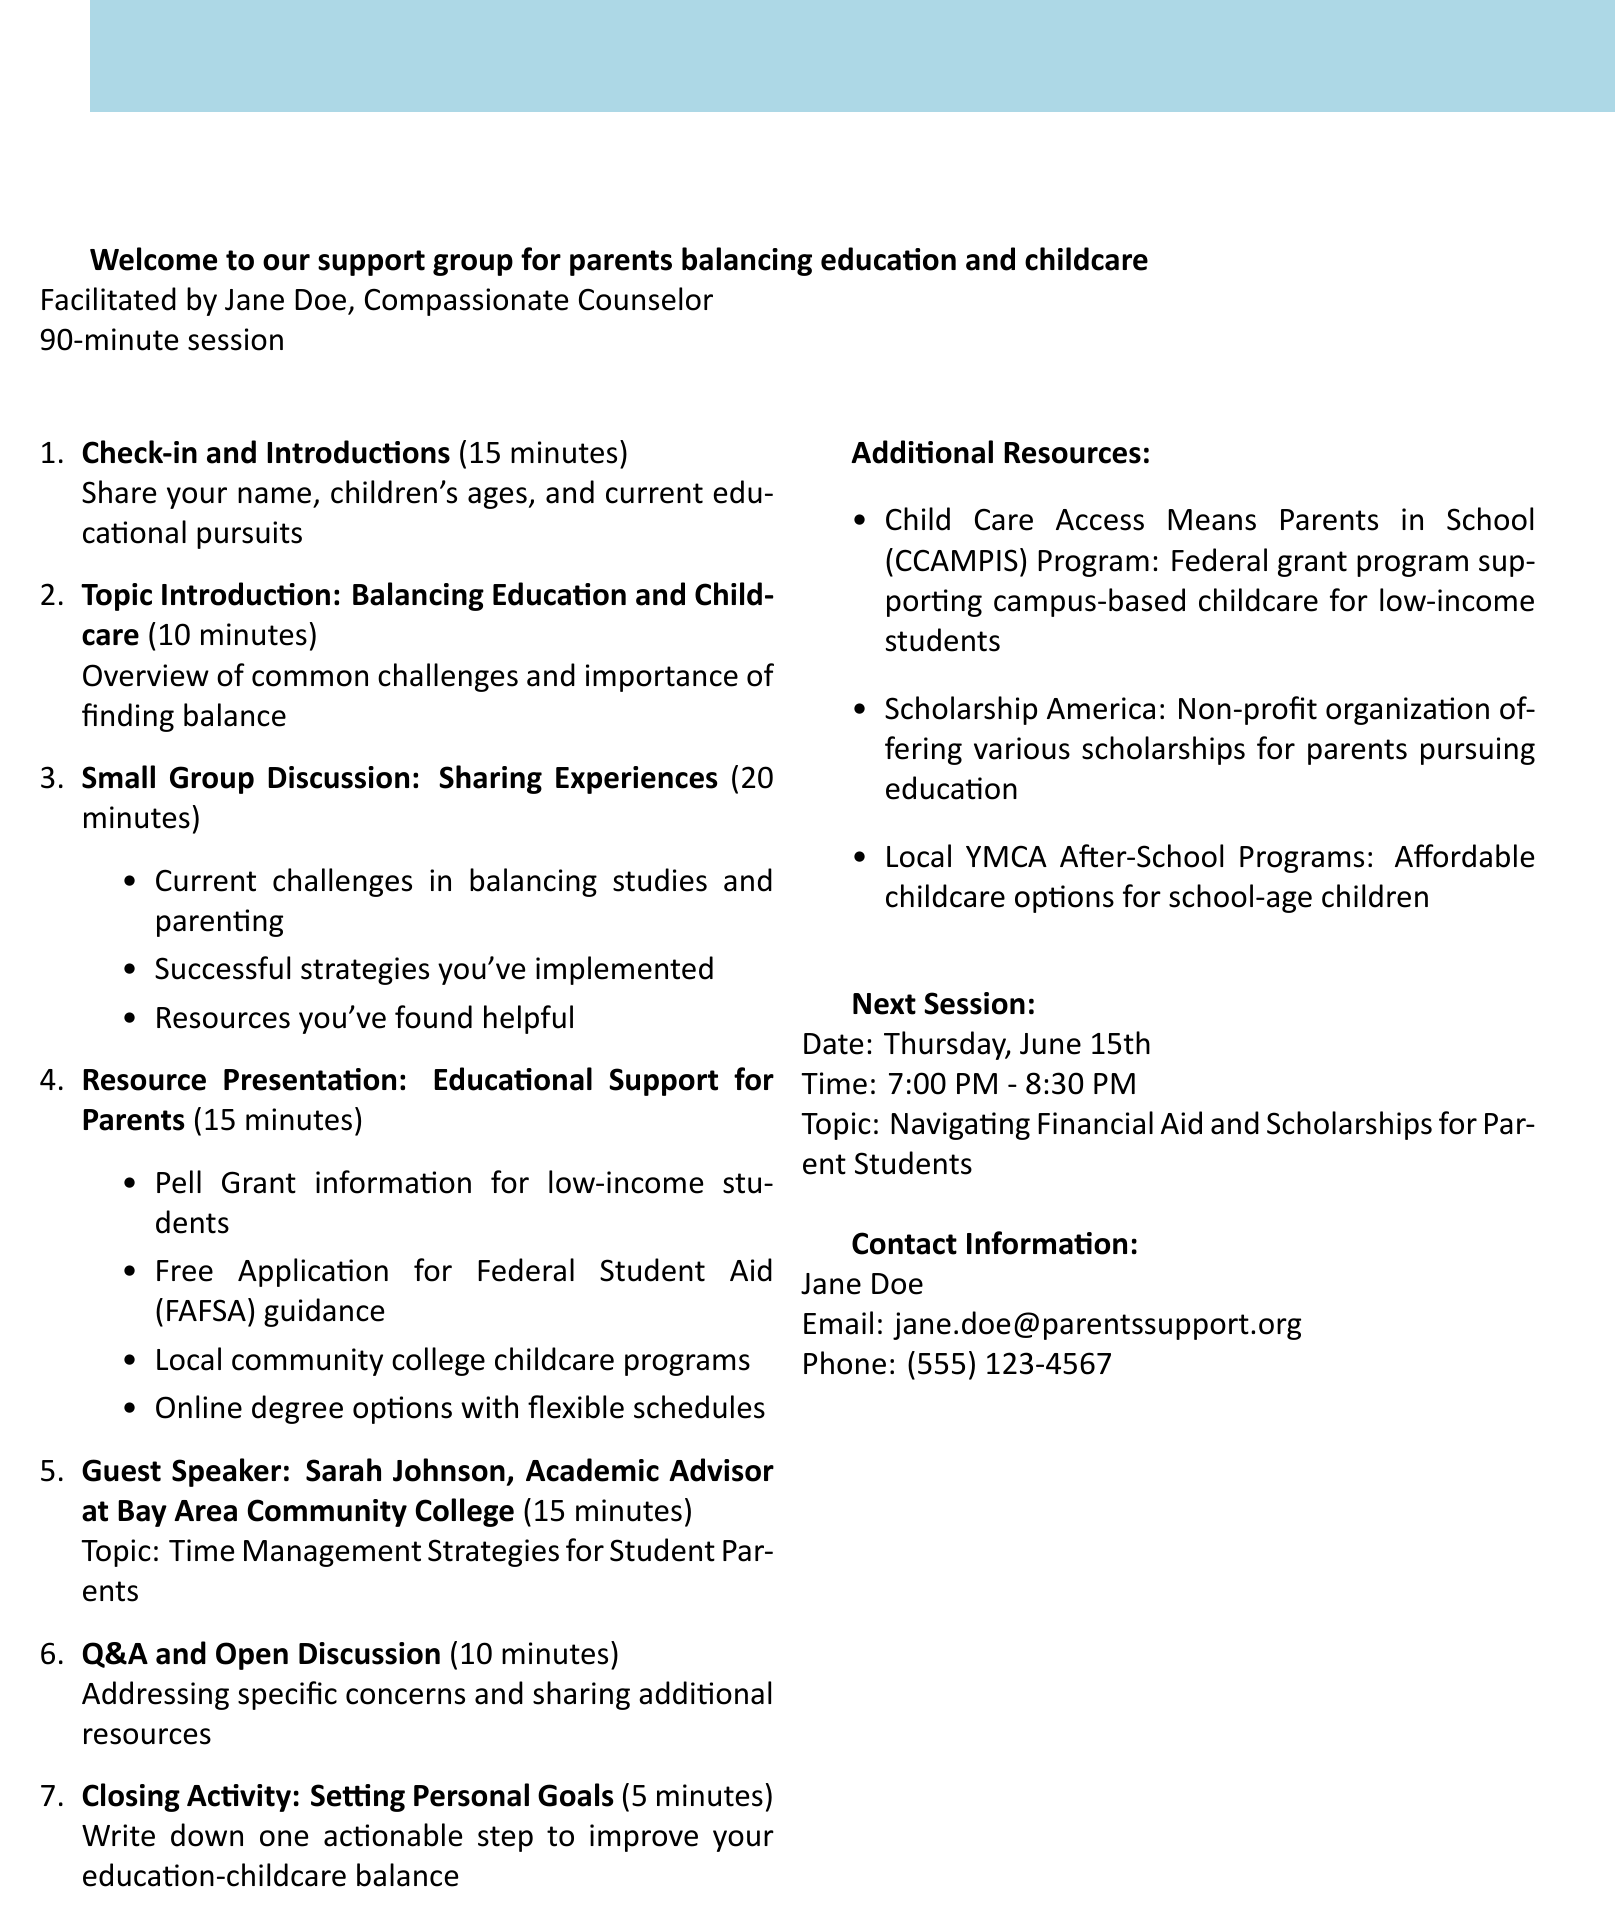What is the facilitator's name? The facilitator's name is mentioned in the introduction section of the document.
Answer: Jane Doe How long is the session scheduled for? The duration of the session is specified in the introduction section.
Answer: 90-minute session What is the date of the next session? The next session's date is provided in the document under the next session section.
Answer: Thursday, June 15th What topic will the guest speaker discuss? The topic of the guest speaker is listed in their section.
Answer: Time Management Strategies for Student Parents How many minutes are allocated for small group discussion? The duration for small group discussion is mentioned in the agenda items section.
Answer: 20 minutes What is one of the resources presented for educational support? The resources are listed in the resource presentation section of the agenda.
Answer: Pell Grant information for low-income students What is the last activity listed in the agenda? The final activity is mentioned at the end of the agenda items.
Answer: Closing Activity: Setting Personal Goals What organization offers scholarships for parents pursuing education? The additional resources section names organizations that provide scholarships.
Answer: Scholarship America What is the contact email for Jane Doe? The contact email is provided in the contact information section.
Answer: jane.doe@parentssupport.org 